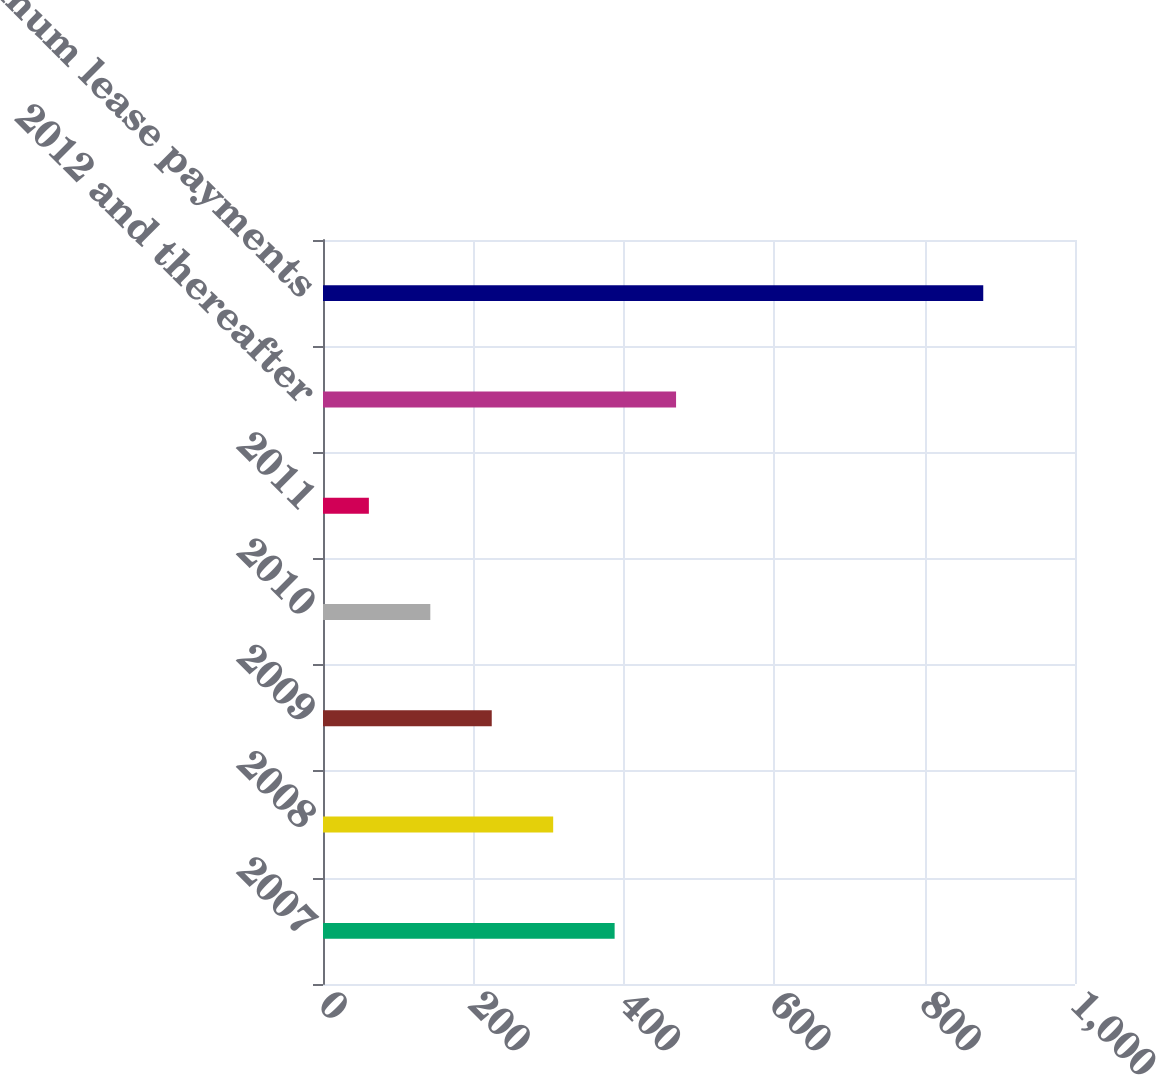<chart> <loc_0><loc_0><loc_500><loc_500><bar_chart><fcel>2007<fcel>2008<fcel>2009<fcel>2010<fcel>2011<fcel>2012 and thereafter<fcel>Total minimum lease payments<nl><fcel>387.8<fcel>306.1<fcel>224.4<fcel>142.7<fcel>61<fcel>469.5<fcel>878<nl></chart> 